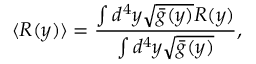Convert formula to latex. <formula><loc_0><loc_0><loc_500><loc_500>\langle R ( y ) \rangle = \frac { \int d ^ { 4 } y \sqrt { \bar { g } ( y ) } R ( y ) } { \int d ^ { 4 } y \sqrt { \bar { g } ( y ) } } ,</formula> 